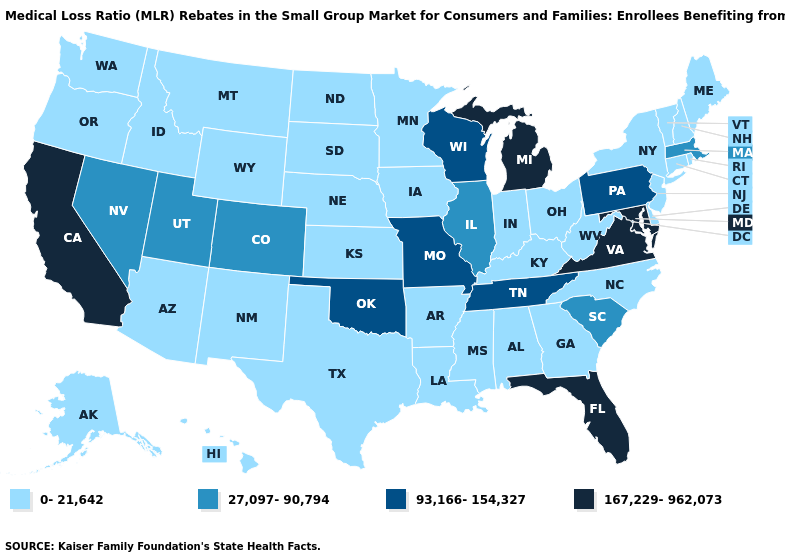Among the states that border Nevada , which have the highest value?
Be succinct. California. What is the value of New Jersey?
Concise answer only. 0-21,642. Which states have the lowest value in the MidWest?
Be succinct. Indiana, Iowa, Kansas, Minnesota, Nebraska, North Dakota, Ohio, South Dakota. What is the lowest value in the West?
Write a very short answer. 0-21,642. Does South Carolina have a lower value than Nebraska?
Give a very brief answer. No. Name the states that have a value in the range 167,229-962,073?
Concise answer only. California, Florida, Maryland, Michigan, Virginia. What is the value of Mississippi?
Be succinct. 0-21,642. Among the states that border New Hampshire , which have the highest value?
Answer briefly. Massachusetts. What is the value of Hawaii?
Be succinct. 0-21,642. What is the value of Oregon?
Concise answer only. 0-21,642. What is the highest value in the USA?
Quick response, please. 167,229-962,073. Does South Carolina have the same value as Georgia?
Quick response, please. No. What is the value of Nevada?
Quick response, please. 27,097-90,794. What is the value of Pennsylvania?
Answer briefly. 93,166-154,327. Does Idaho have a lower value than Kansas?
Quick response, please. No. 